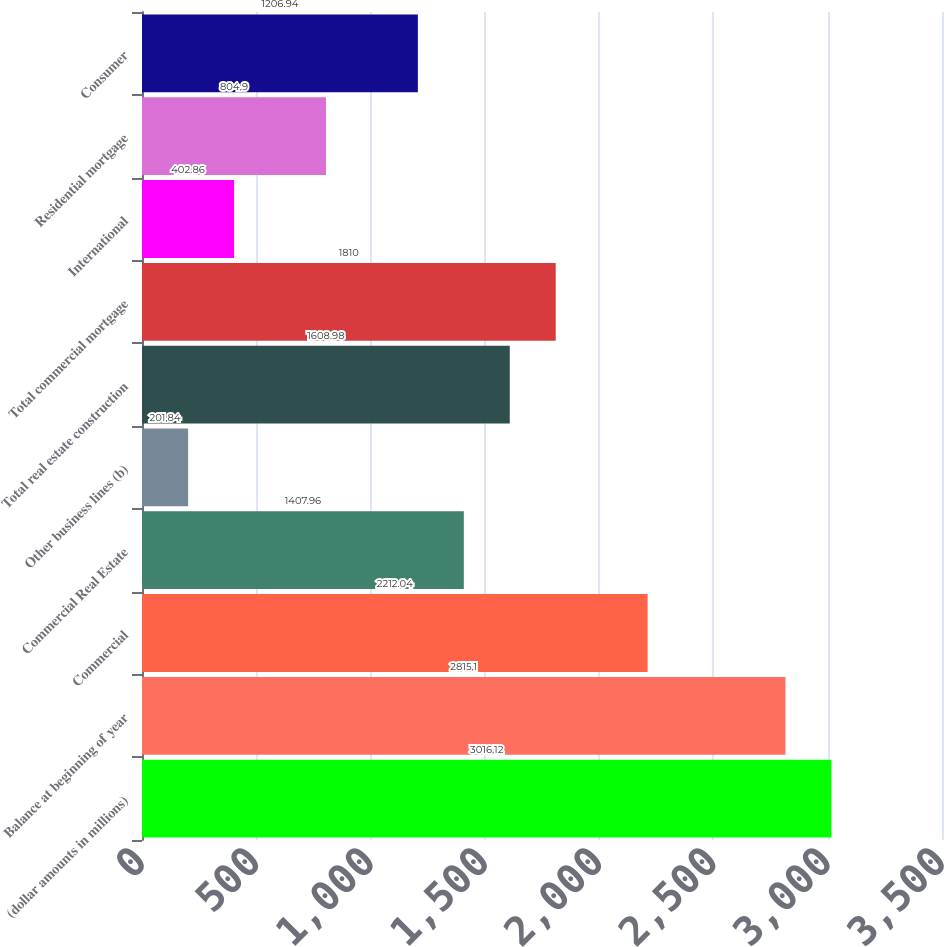Convert chart to OTSL. <chart><loc_0><loc_0><loc_500><loc_500><bar_chart><fcel>(dollar amounts in millions)<fcel>Balance at beginning of year<fcel>Commercial<fcel>Commercial Real Estate<fcel>Other business lines (b)<fcel>Total real estate construction<fcel>Total commercial mortgage<fcel>International<fcel>Residential mortgage<fcel>Consumer<nl><fcel>3016.12<fcel>2815.1<fcel>2212.04<fcel>1407.96<fcel>201.84<fcel>1608.98<fcel>1810<fcel>402.86<fcel>804.9<fcel>1206.94<nl></chart> 